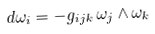Convert formula to latex. <formula><loc_0><loc_0><loc_500><loc_500>d \omega _ { i } = - g _ { i j k } \, \omega _ { j } \wedge \omega _ { k }</formula> 